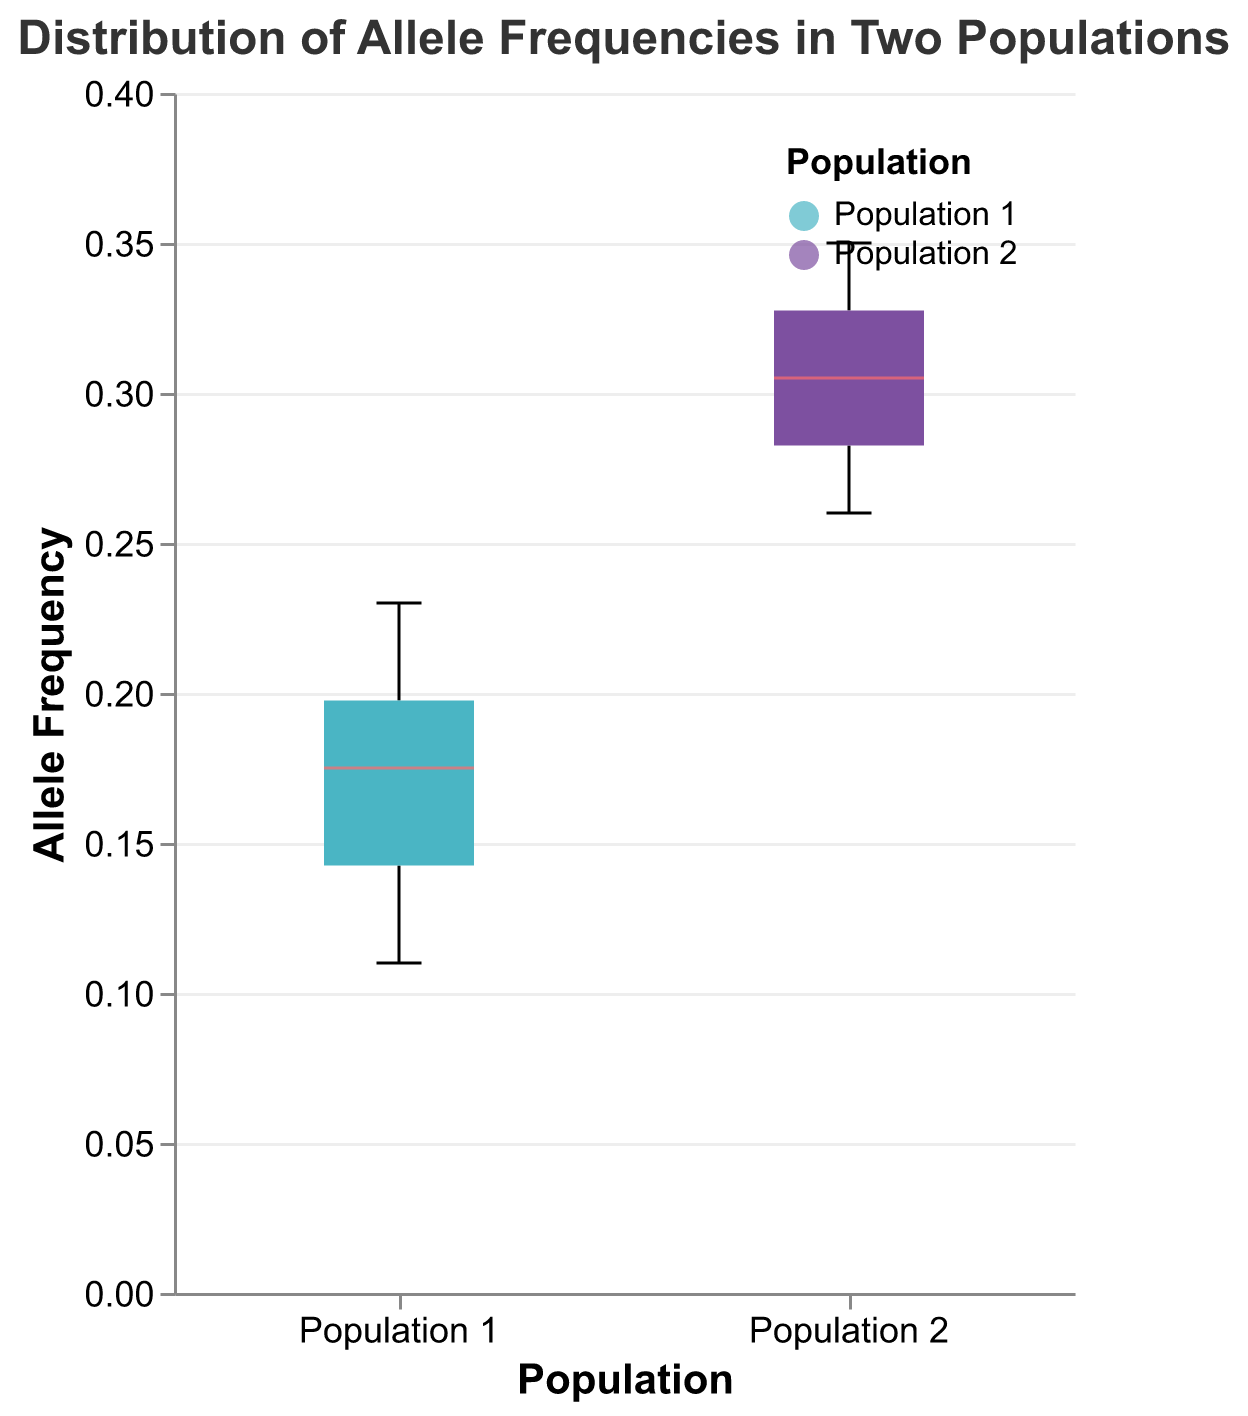What is the title of the figure? The title is clearly displayed at the top of the figure. It reads "Distribution of Allele Frequencies in Two Populations".
Answer: Distribution of Allele Frequencies in Two Populations How many populations are included in the figure? The x-axis labels show two distinct groups: Population 1 and Population 2.
Answer: 2 What are the median allele frequencies for Population 1 and Population 2? The median allele frequency is marked by a red line within each box plot. For Population 1, the median is around 0.18, and for Population 2, it is roughly 0.30.
Answer: 0.18 and 0.30 Which population has a higher variability in allele frequencies? The variability in allele frequencies can be inferred from the spread of the box plots. Population 1 shows a larger interquartile range and is more spread out compared to Population 2.
Answer: Population 1 What is the range of allele frequencies in Population 2? The range can be assessed by looking at the whiskers of the box plot for Population 2, which extend from around 0.26 to 0.35.
Answer: 0.26 to 0.35 Does Population 1 have any outliers? Outliers are indicated by points outside the whiskers of the box plot. There are no points beyond the whiskers in Population 1, indicating no outliers.
Answer: No What is the interquartile range (IQR) for Population 1? The IQR is the range between the first quartile (Q1) and third quartile (Q3). For Population 1, Q1 is around 0.14 and Q3 is approximately 0.21, so the IQR is 0.21 - 0.14.
Answer: 0.07 Which population has the maximum allele frequency value and what is it? The maximum value for each population is indicated by the top whisker. For Population 2, the top whisker is around 0.35, whereas for Population 1, it is approx. 0.23. Thus, Population 2 has the maximum allele frequency.
Answer: Population 2, 0.35 How do the colors differentiate the two populations? The box plots use different colors to differentiate between the populations: Population 1 is represented by a turquoise color, and Population 2 by a purple color.
Answer: Turquoise for Population 1 and purple for Population 2 In terms of median allele frequency, how much higher is Population 2 compared to Population 1? The median allele frequency for Population 1 is around 0.18, while for Population 2, it is approximately 0.30. The difference is 0.30 - 0.18.
Answer: 0.12 